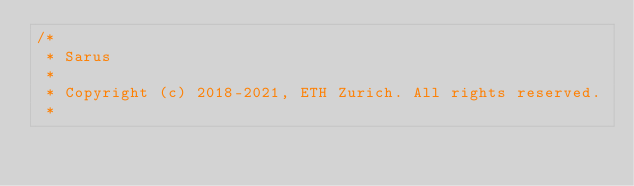Convert code to text. <code><loc_0><loc_0><loc_500><loc_500><_C++_>/*
 * Sarus
 *
 * Copyright (c) 2018-2021, ETH Zurich. All rights reserved.
 *</code> 